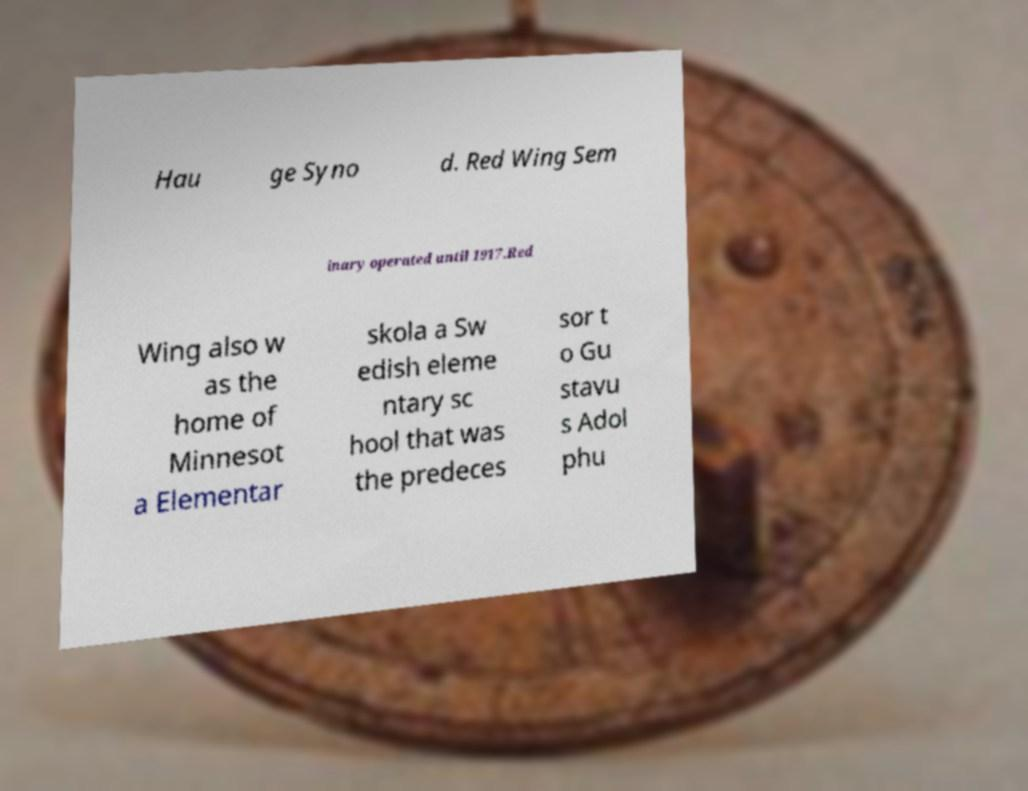Please identify and transcribe the text found in this image. Hau ge Syno d. Red Wing Sem inary operated until 1917.Red Wing also w as the home of Minnesot a Elementar skola a Sw edish eleme ntary sc hool that was the predeces sor t o Gu stavu s Adol phu 